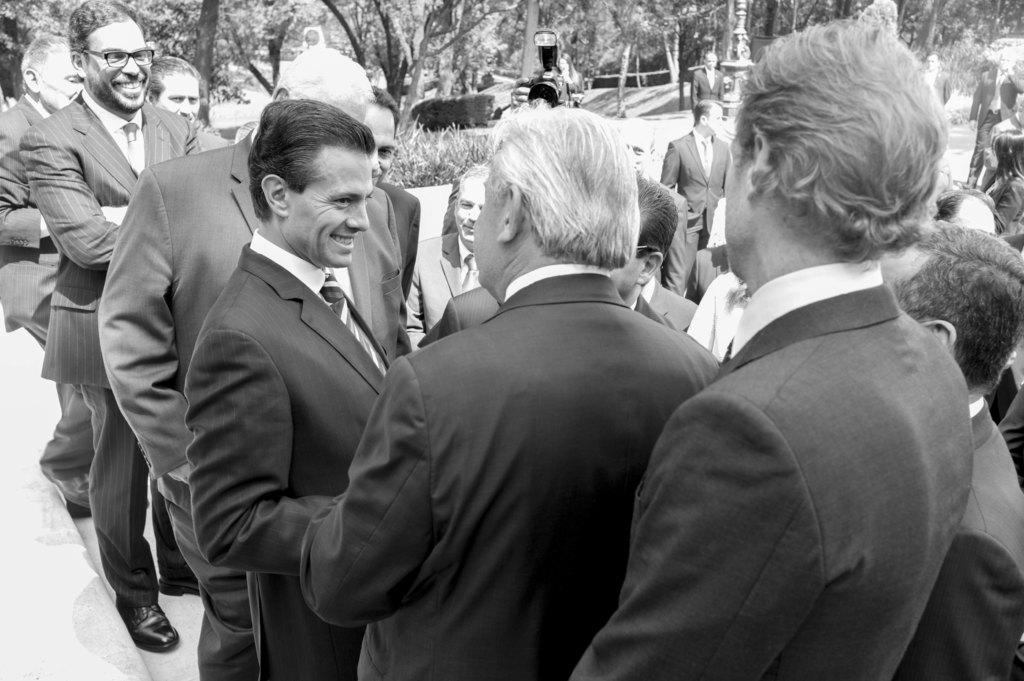What is happening in the image? There is a group of people standing in the image. What can be seen in the background of the image? There are trees and other objects on the ground in the background of the image. What is the color scheme of the image? The image is black and white in color. What is the value of the journey depicted in the image? There is no journey depicted in the image, as it only shows a group of people standing and the background. 